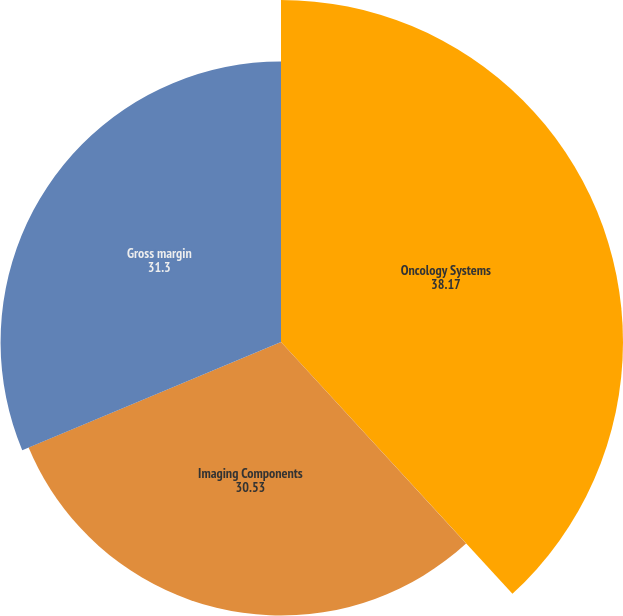<chart> <loc_0><loc_0><loc_500><loc_500><pie_chart><fcel>Oncology Systems<fcel>Imaging Components<fcel>Gross margin<nl><fcel>38.17%<fcel>30.53%<fcel>31.3%<nl></chart> 